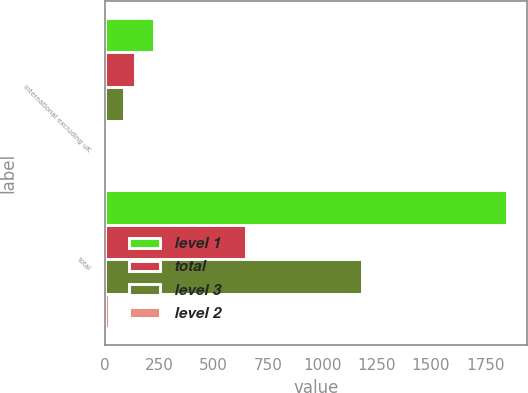<chart> <loc_0><loc_0><loc_500><loc_500><stacked_bar_chart><ecel><fcel>international excluding uK<fcel>total<nl><fcel>level 1<fcel>225<fcel>1851<nl><fcel>total<fcel>137<fcel>650<nl><fcel>level 3<fcel>87<fcel>1183<nl><fcel>level 2<fcel>1<fcel>18<nl></chart> 